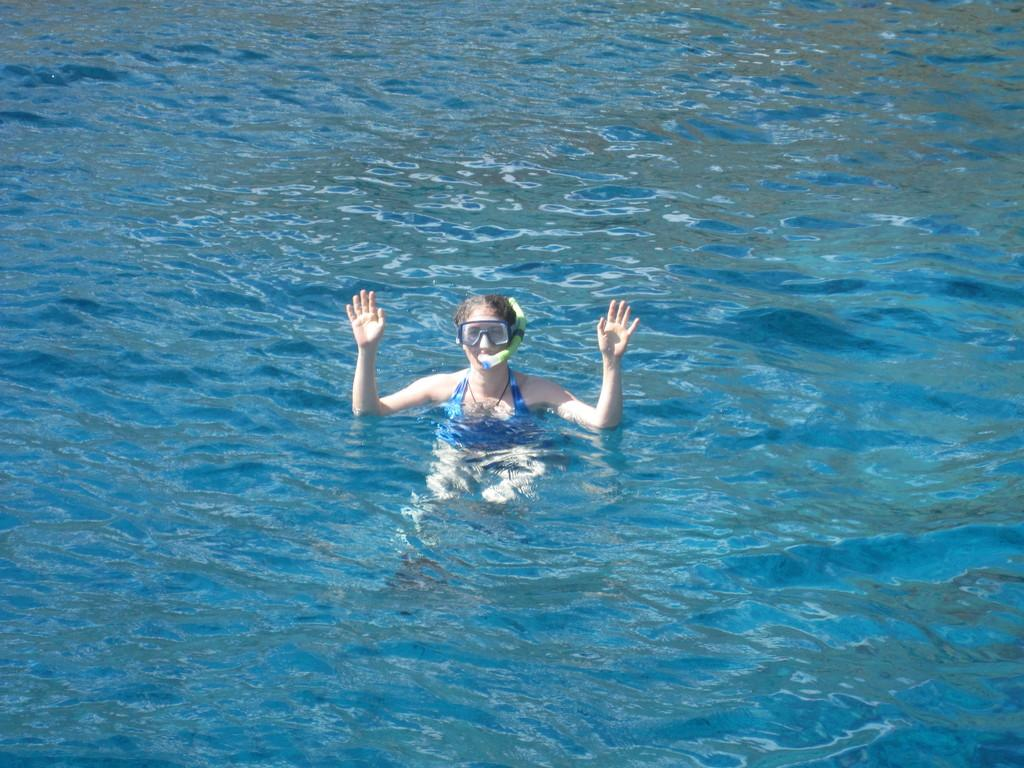Who is present in the image? There is a woman in the image. What is happening to the woman in the image? The woman is drowning in the water. What is the primary element in which the woman is situated? The woman is situated in water. What color is the blood on the woman's face in the image? There is no blood visible on the woman's face in the image. 